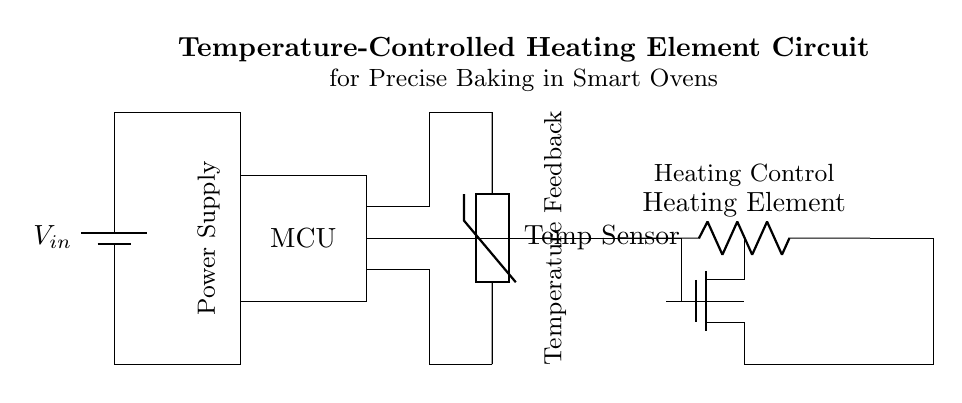What is the primary function of the MCU in this circuit? The primary function of the MCU (Microcontroller Unit) is to manage the overall operation of the circuit, including processing signals from the temperature sensor and controlling the heating element based on the temperature feedback.
Answer: Manage operation What component detects temperature changes? The component responsible for detecting temperature changes is the thermistor, which is a type of temperature sensor that changes its resistance according to the temperature.
Answer: Thermistor What type of control is used for the heating element? The heating element is controlled by a MOSFET, which serves as a switch that regulates power to the heating element based on signals from the microcontroller.
Answer: MOSFET How is the power supply connected to the microcontroller? The power supply is connected to the microcontroller through conductive lines that carry the input voltage directly from the battery to the microcontroller's power input terminals.
Answer: Directly connected What is the relation between the temperature sensor and the heating element? The temperature sensor provides feedback to the microcontroller, which calculates whether to activate or deactivate the heating element based on the measured temperature, ensuring precise temperature control.
Answer: Feedback loop What role does the mosfet play in the circuit? The MOSFET acts as a switch to control the power supplied to the heating element, allowing the microcontroller to turn the heating element on or off to maintain a specified temperature.
Answer: Power control 